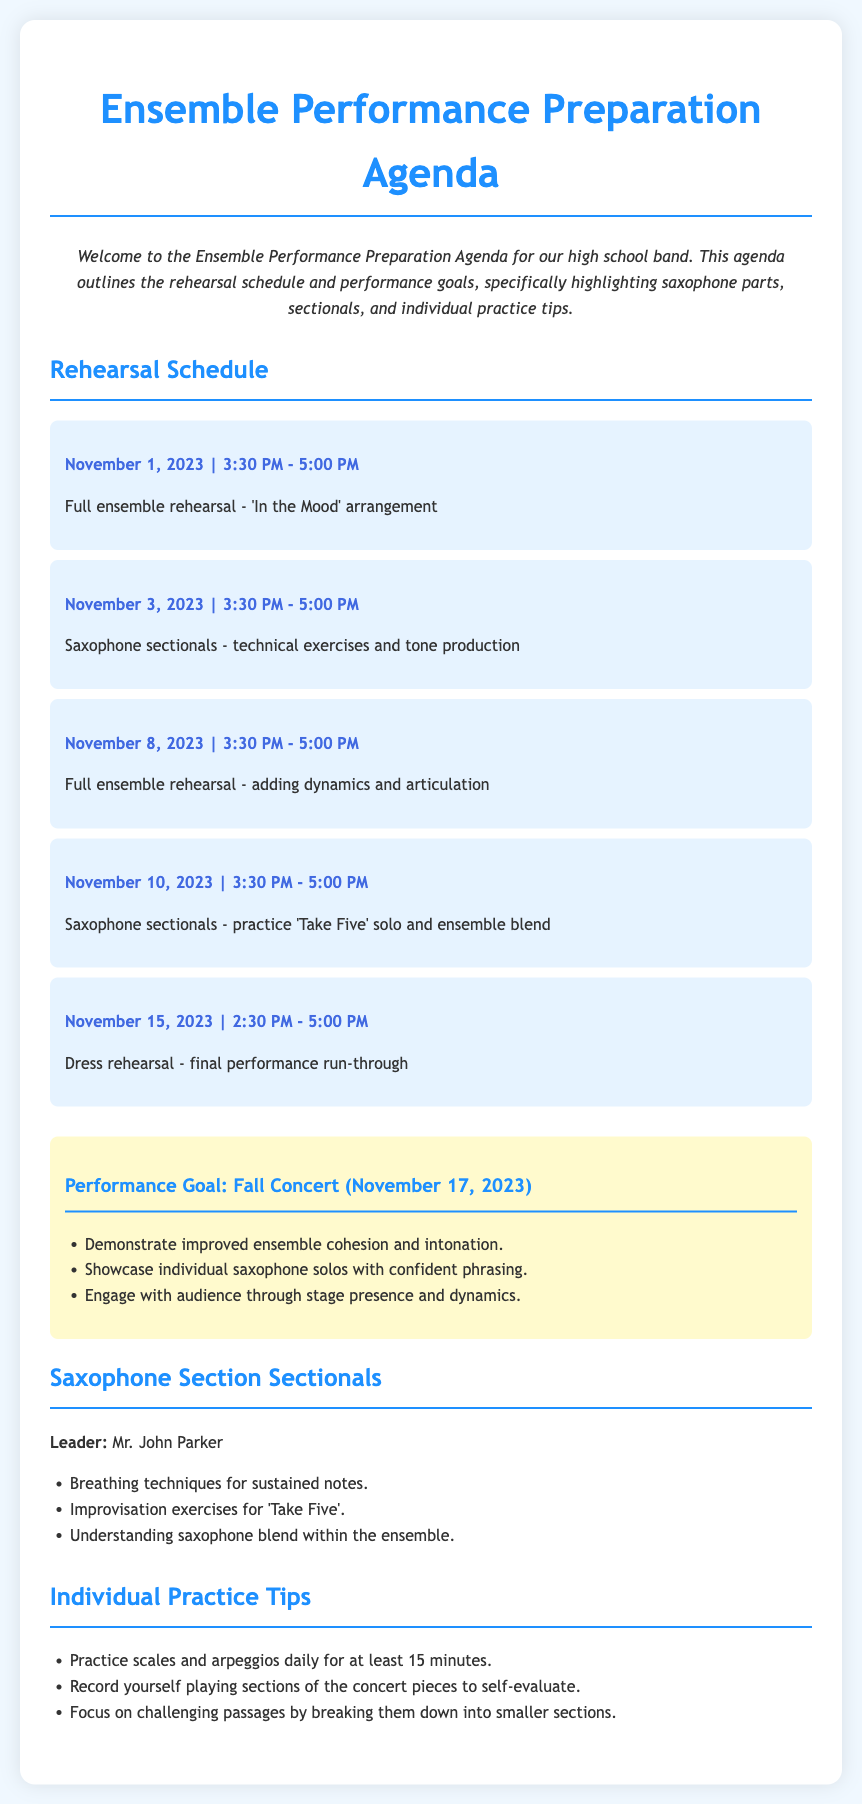what is the date of the dress rehearsal? The dress rehearsal is scheduled for November 15, 2023.
Answer: November 15, 2023 who is the saxophone sectional leader? The saxophone sectional leader is Mr. John Parker.
Answer: Mr. John Parker what is the focus of the rehearsal on November 3, 2023? The focus is on technical exercises and tone production for saxophones.
Answer: technical exercises and tone production how many performance goals are listed for the Fall Concert? There are three performance goals listed for the Fall Concert.
Answer: three what piece is featured for improvisation exercises in the sectionals? The piece featured for improvisation exercises is 'Take Five'.
Answer: 'Take Five' what time does the full ensemble rehearsal on November 8, 2023, start? The full ensemble rehearsal starts at 3:30 PM.
Answer: 3:30 PM what is one individual practice tip provided in the agenda? One individual practice tip is to practice scales and arpeggios daily.
Answer: practice scales and arpeggios daily how long is each rehearsal session scheduled to last? Each rehearsal session is scheduled to last 1.5 hours.
Answer: 1.5 hours 